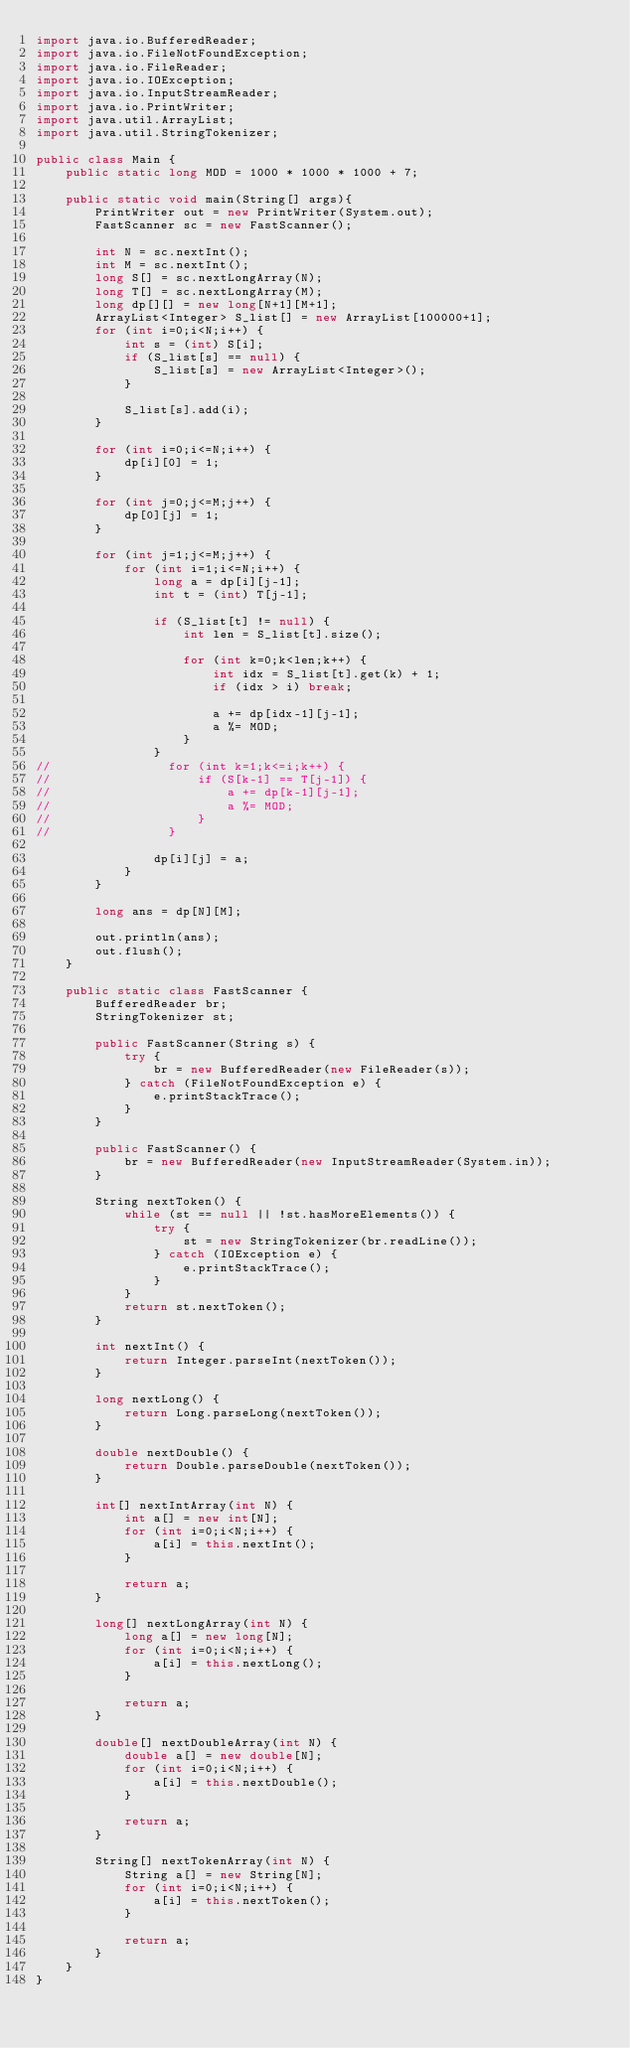<code> <loc_0><loc_0><loc_500><loc_500><_Java_>import java.io.BufferedReader;
import java.io.FileNotFoundException;
import java.io.FileReader;
import java.io.IOException;
import java.io.InputStreamReader;
import java.io.PrintWriter;
import java.util.ArrayList;
import java.util.StringTokenizer;

public class Main {
    public static long MOD = 1000 * 1000 * 1000 + 7;

    public static void main(String[] args){
        PrintWriter out = new PrintWriter(System.out);
        FastScanner sc = new FastScanner();

        int N = sc.nextInt();
        int M = sc.nextInt();
        long S[] = sc.nextLongArray(N);
        long T[] = sc.nextLongArray(M);
        long dp[][] = new long[N+1][M+1];
        ArrayList<Integer> S_list[] = new ArrayList[100000+1];
        for (int i=0;i<N;i++) {
            int s = (int) S[i];
            if (S_list[s] == null) {
                S_list[s] = new ArrayList<Integer>();
            }

            S_list[s].add(i);
        }

        for (int i=0;i<=N;i++) {
            dp[i][0] = 1;
        }

        for (int j=0;j<=M;j++) {
            dp[0][j] = 1;
        }

        for (int j=1;j<=M;j++) {
            for (int i=1;i<=N;i++) {
                long a = dp[i][j-1];
                int t = (int) T[j-1];

                if (S_list[t] != null) {
                    int len = S_list[t].size();

                    for (int k=0;k<len;k++) {
                        int idx = S_list[t].get(k) + 1;
                        if (idx > i) break;

                        a += dp[idx-1][j-1];
                        a %= MOD;
                    }
                }
//                for (int k=1;k<=i;k++) {
//                    if (S[k-1] == T[j-1]) {
//                        a += dp[k-1][j-1];
//                        a %= MOD;
//                    }
//                }

                dp[i][j] = a;
            }
        }

        long ans = dp[N][M];

        out.println(ans);
        out.flush();
    }

    public static class FastScanner {
        BufferedReader br;
        StringTokenizer st;

        public FastScanner(String s) {
            try {
                br = new BufferedReader(new FileReader(s));
            } catch (FileNotFoundException e) {
                e.printStackTrace();
            }
        }

        public FastScanner() {
            br = new BufferedReader(new InputStreamReader(System.in));
        }

        String nextToken() {
            while (st == null || !st.hasMoreElements()) {
                try {
                    st = new StringTokenizer(br.readLine());
                } catch (IOException e) {
                    e.printStackTrace();
                }
            }
            return st.nextToken();
        }

        int nextInt() {
            return Integer.parseInt(nextToken());
        }

        long nextLong() {
            return Long.parseLong(nextToken());
        }

        double nextDouble() {
            return Double.parseDouble(nextToken());
        }

        int[] nextIntArray(int N) {
            int a[] = new int[N];
            for (int i=0;i<N;i++) {
                a[i] = this.nextInt();
            }

            return a;
        }

        long[] nextLongArray(int N) {
            long a[] = new long[N];
            for (int i=0;i<N;i++) {
                a[i] = this.nextLong();
            }

            return a;
        }

        double[] nextDoubleArray(int N) {
            double a[] = new double[N];
            for (int i=0;i<N;i++) {
                a[i] = this.nextDouble();
            }

            return a;
        }

        String[] nextTokenArray(int N) {
            String a[] = new String[N];
            for (int i=0;i<N;i++) {
                a[i] = this.nextToken();
            }

            return a;
        }
    }
}</code> 